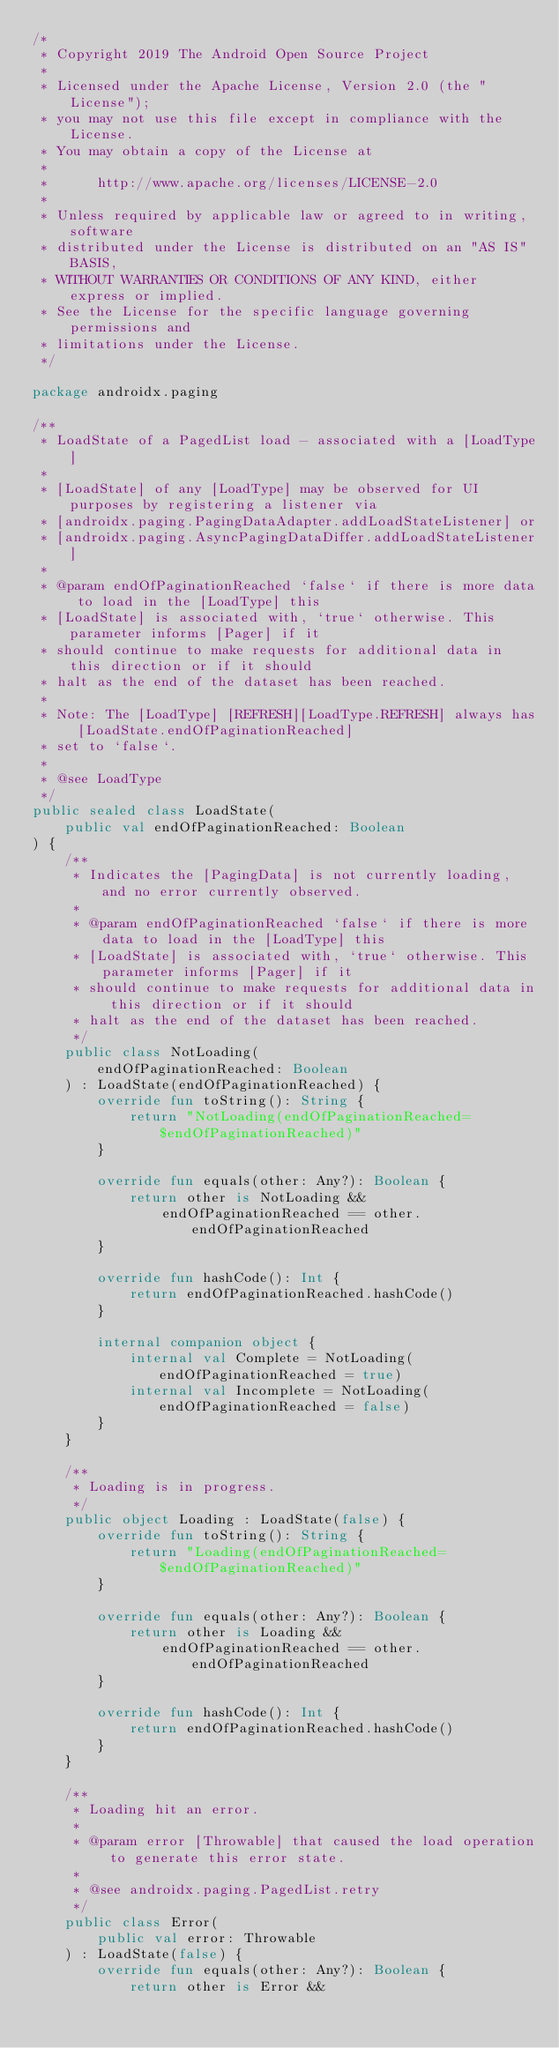<code> <loc_0><loc_0><loc_500><loc_500><_Kotlin_>/*
 * Copyright 2019 The Android Open Source Project
 *
 * Licensed under the Apache License, Version 2.0 (the "License");
 * you may not use this file except in compliance with the License.
 * You may obtain a copy of the License at
 *
 *      http://www.apache.org/licenses/LICENSE-2.0
 *
 * Unless required by applicable law or agreed to in writing, software
 * distributed under the License is distributed on an "AS IS" BASIS,
 * WITHOUT WARRANTIES OR CONDITIONS OF ANY KIND, either express or implied.
 * See the License for the specific language governing permissions and
 * limitations under the License.
 */

package androidx.paging

/**
 * LoadState of a PagedList load - associated with a [LoadType]
 *
 * [LoadState] of any [LoadType] may be observed for UI purposes by registering a listener via
 * [androidx.paging.PagingDataAdapter.addLoadStateListener] or
 * [androidx.paging.AsyncPagingDataDiffer.addLoadStateListener]
 *
 * @param endOfPaginationReached `false` if there is more data to load in the [LoadType] this
 * [LoadState] is associated with, `true` otherwise. This parameter informs [Pager] if it
 * should continue to make requests for additional data in this direction or if it should
 * halt as the end of the dataset has been reached.
 *
 * Note: The [LoadType] [REFRESH][LoadType.REFRESH] always has [LoadState.endOfPaginationReached]
 * set to `false`.
 *
 * @see LoadType
 */
public sealed class LoadState(
    public val endOfPaginationReached: Boolean
) {
    /**
     * Indicates the [PagingData] is not currently loading, and no error currently observed.
     *
     * @param endOfPaginationReached `false` if there is more data to load in the [LoadType] this
     * [LoadState] is associated with, `true` otherwise. This parameter informs [Pager] if it
     * should continue to make requests for additional data in this direction or if it should
     * halt as the end of the dataset has been reached.
     */
    public class NotLoading(
        endOfPaginationReached: Boolean
    ) : LoadState(endOfPaginationReached) {
        override fun toString(): String {
            return "NotLoading(endOfPaginationReached=$endOfPaginationReached)"
        }

        override fun equals(other: Any?): Boolean {
            return other is NotLoading &&
                endOfPaginationReached == other.endOfPaginationReached
        }

        override fun hashCode(): Int {
            return endOfPaginationReached.hashCode()
        }

        internal companion object {
            internal val Complete = NotLoading(endOfPaginationReached = true)
            internal val Incomplete = NotLoading(endOfPaginationReached = false)
        }
    }

    /**
     * Loading is in progress.
     */
    public object Loading : LoadState(false) {
        override fun toString(): String {
            return "Loading(endOfPaginationReached=$endOfPaginationReached)"
        }

        override fun equals(other: Any?): Boolean {
            return other is Loading &&
                endOfPaginationReached == other.endOfPaginationReached
        }

        override fun hashCode(): Int {
            return endOfPaginationReached.hashCode()
        }
    }

    /**
     * Loading hit an error.
     *
     * @param error [Throwable] that caused the load operation to generate this error state.
     *
     * @see androidx.paging.PagedList.retry
     */
    public class Error(
        public val error: Throwable
    ) : LoadState(false) {
        override fun equals(other: Any?): Boolean {
            return other is Error &&</code> 